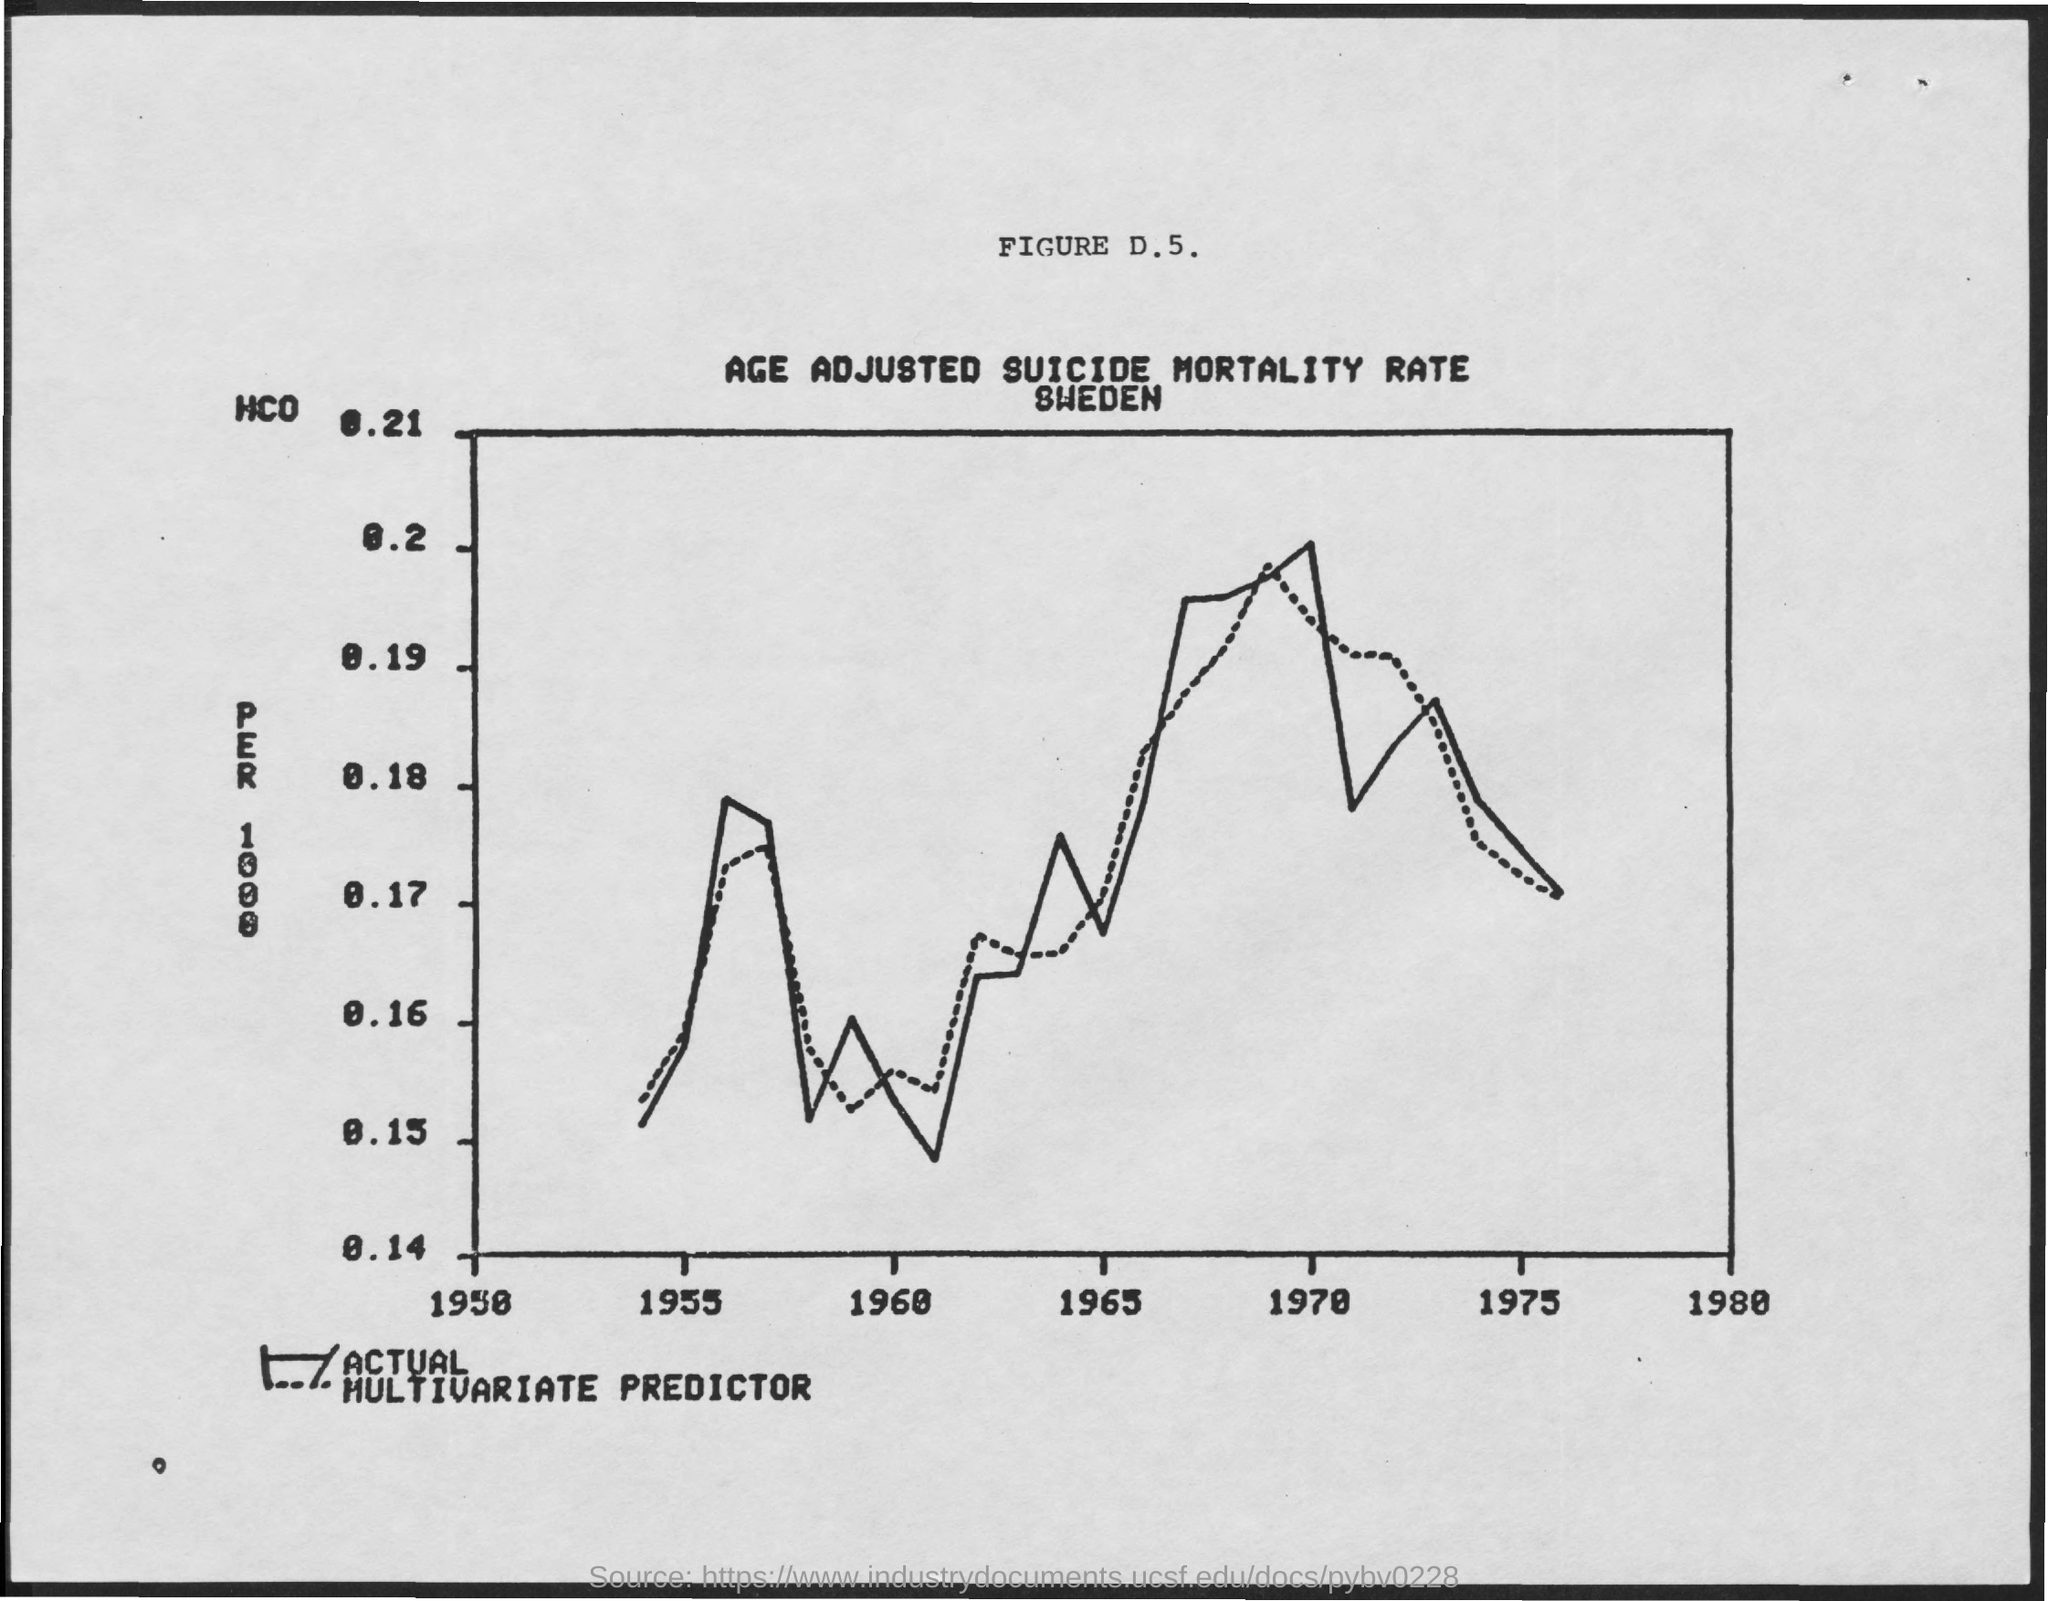What is the figure number mentioned ?
Ensure brevity in your answer.  D. 5. What is the title of the figure
Your response must be concise. Age adjusted suicide mortality rate sweden. 